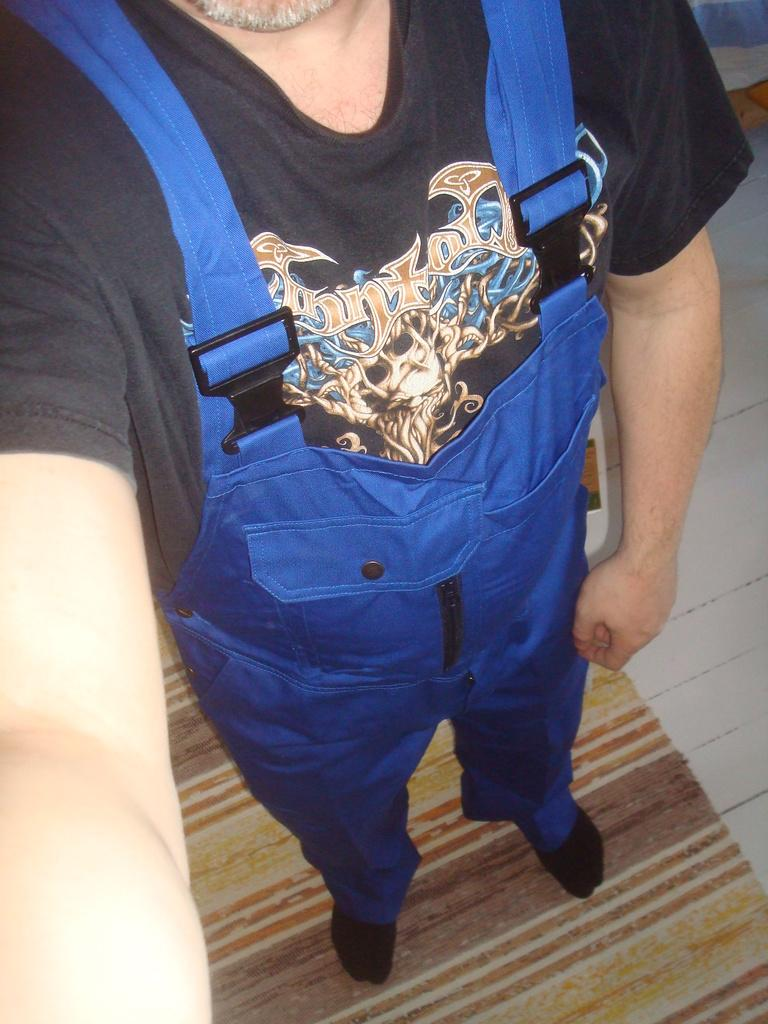What can be seen in the image? There is a person in the image. Can you describe the person's appearance? The person's face is not visible in the image. What is the person wearing? The person is wearing clothes. What is on the floor in the image? There is a mat on the floor in the image. What type of ink is the person using to write on the desk in the image? There is no desk or ink present in the image; the person's face is not visible, and there is no mention of writing or a desk. 